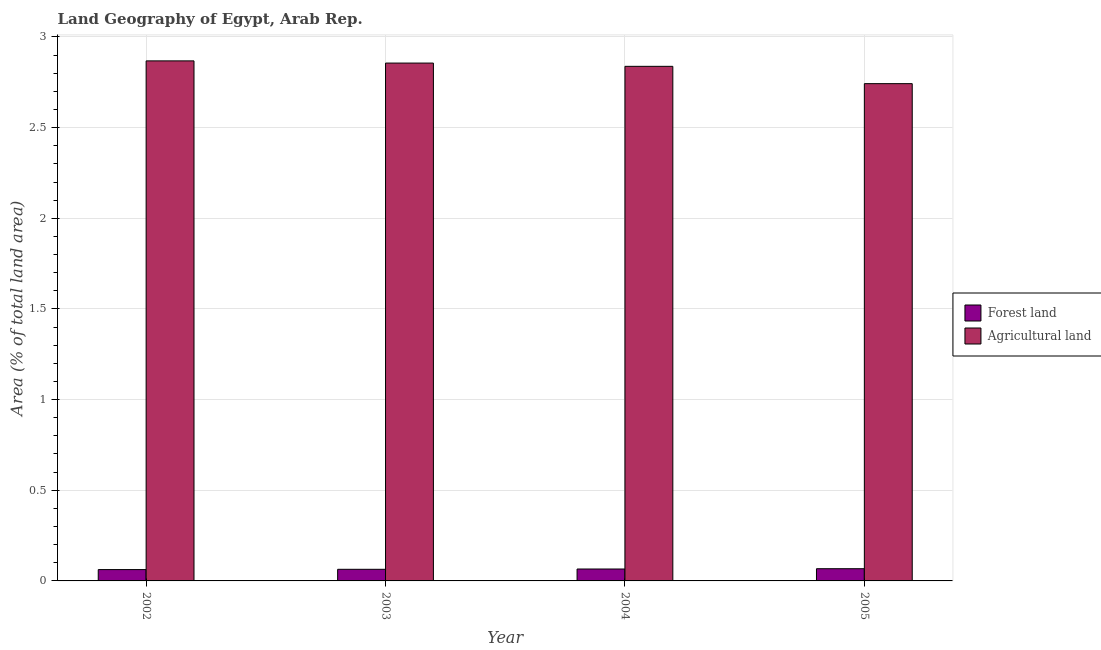How many groups of bars are there?
Your response must be concise. 4. Are the number of bars on each tick of the X-axis equal?
Your answer should be very brief. Yes. How many bars are there on the 3rd tick from the left?
Your answer should be compact. 2. How many bars are there on the 1st tick from the right?
Ensure brevity in your answer.  2. What is the label of the 4th group of bars from the left?
Offer a terse response. 2005. In how many cases, is the number of bars for a given year not equal to the number of legend labels?
Give a very brief answer. 0. What is the percentage of land area under agriculture in 2003?
Your answer should be compact. 2.86. Across all years, what is the maximum percentage of land area under agriculture?
Your response must be concise. 2.87. Across all years, what is the minimum percentage of land area under forests?
Provide a short and direct response. 0.06. In which year was the percentage of land area under agriculture minimum?
Provide a succinct answer. 2005. What is the total percentage of land area under agriculture in the graph?
Offer a very short reply. 11.3. What is the difference between the percentage of land area under forests in 2002 and that in 2005?
Your answer should be compact. -0. What is the difference between the percentage of land area under forests in 2003 and the percentage of land area under agriculture in 2004?
Offer a very short reply. -0. What is the average percentage of land area under agriculture per year?
Make the answer very short. 2.83. What is the ratio of the percentage of land area under forests in 2003 to that in 2005?
Provide a short and direct response. 0.95. What is the difference between the highest and the second highest percentage of land area under forests?
Offer a very short reply. 0. What is the difference between the highest and the lowest percentage of land area under agriculture?
Offer a terse response. 0.13. In how many years, is the percentage of land area under agriculture greater than the average percentage of land area under agriculture taken over all years?
Provide a succinct answer. 3. Is the sum of the percentage of land area under forests in 2002 and 2004 greater than the maximum percentage of land area under agriculture across all years?
Provide a short and direct response. Yes. What does the 1st bar from the left in 2002 represents?
Offer a very short reply. Forest land. What does the 2nd bar from the right in 2003 represents?
Keep it short and to the point. Forest land. How many bars are there?
Offer a very short reply. 8. How many years are there in the graph?
Your response must be concise. 4. What is the difference between two consecutive major ticks on the Y-axis?
Give a very brief answer. 0.5. Does the graph contain any zero values?
Your answer should be very brief. No. Does the graph contain grids?
Provide a succinct answer. Yes. Where does the legend appear in the graph?
Make the answer very short. Center right. How are the legend labels stacked?
Give a very brief answer. Vertical. What is the title of the graph?
Keep it short and to the point. Land Geography of Egypt, Arab Rep. Does "Residents" appear as one of the legend labels in the graph?
Offer a terse response. No. What is the label or title of the X-axis?
Offer a very short reply. Year. What is the label or title of the Y-axis?
Ensure brevity in your answer.  Area (% of total land area). What is the Area (% of total land area) in Forest land in 2002?
Offer a very short reply. 0.06. What is the Area (% of total land area) in Agricultural land in 2002?
Your response must be concise. 2.87. What is the Area (% of total land area) in Forest land in 2003?
Ensure brevity in your answer.  0.06. What is the Area (% of total land area) in Agricultural land in 2003?
Your answer should be compact. 2.86. What is the Area (% of total land area) of Forest land in 2004?
Provide a short and direct response. 0.07. What is the Area (% of total land area) of Agricultural land in 2004?
Keep it short and to the point. 2.84. What is the Area (% of total land area) in Forest land in 2005?
Offer a very short reply. 0.07. What is the Area (% of total land area) in Agricultural land in 2005?
Provide a succinct answer. 2.74. Across all years, what is the maximum Area (% of total land area) in Forest land?
Your answer should be compact. 0.07. Across all years, what is the maximum Area (% of total land area) in Agricultural land?
Your response must be concise. 2.87. Across all years, what is the minimum Area (% of total land area) in Forest land?
Your answer should be very brief. 0.06. Across all years, what is the minimum Area (% of total land area) of Agricultural land?
Ensure brevity in your answer.  2.74. What is the total Area (% of total land area) of Forest land in the graph?
Provide a short and direct response. 0.26. What is the total Area (% of total land area) in Agricultural land in the graph?
Provide a succinct answer. 11.3. What is the difference between the Area (% of total land area) of Forest land in 2002 and that in 2003?
Keep it short and to the point. -0. What is the difference between the Area (% of total land area) in Agricultural land in 2002 and that in 2003?
Provide a succinct answer. 0.01. What is the difference between the Area (% of total land area) of Forest land in 2002 and that in 2004?
Provide a short and direct response. -0. What is the difference between the Area (% of total land area) of Agricultural land in 2002 and that in 2004?
Your answer should be very brief. 0.03. What is the difference between the Area (% of total land area) of Forest land in 2002 and that in 2005?
Offer a very short reply. -0. What is the difference between the Area (% of total land area) in Agricultural land in 2002 and that in 2005?
Provide a succinct answer. 0.13. What is the difference between the Area (% of total land area) in Forest land in 2003 and that in 2004?
Keep it short and to the point. -0. What is the difference between the Area (% of total land area) of Agricultural land in 2003 and that in 2004?
Give a very brief answer. 0.02. What is the difference between the Area (% of total land area) of Forest land in 2003 and that in 2005?
Your response must be concise. -0. What is the difference between the Area (% of total land area) of Agricultural land in 2003 and that in 2005?
Offer a very short reply. 0.11. What is the difference between the Area (% of total land area) in Forest land in 2004 and that in 2005?
Give a very brief answer. -0. What is the difference between the Area (% of total land area) in Agricultural land in 2004 and that in 2005?
Ensure brevity in your answer.  0.1. What is the difference between the Area (% of total land area) in Forest land in 2002 and the Area (% of total land area) in Agricultural land in 2003?
Your answer should be compact. -2.79. What is the difference between the Area (% of total land area) of Forest land in 2002 and the Area (% of total land area) of Agricultural land in 2004?
Give a very brief answer. -2.78. What is the difference between the Area (% of total land area) in Forest land in 2002 and the Area (% of total land area) in Agricultural land in 2005?
Keep it short and to the point. -2.68. What is the difference between the Area (% of total land area) in Forest land in 2003 and the Area (% of total land area) in Agricultural land in 2004?
Make the answer very short. -2.77. What is the difference between the Area (% of total land area) in Forest land in 2003 and the Area (% of total land area) in Agricultural land in 2005?
Keep it short and to the point. -2.68. What is the difference between the Area (% of total land area) of Forest land in 2004 and the Area (% of total land area) of Agricultural land in 2005?
Your response must be concise. -2.68. What is the average Area (% of total land area) in Forest land per year?
Make the answer very short. 0.06. What is the average Area (% of total land area) of Agricultural land per year?
Your answer should be very brief. 2.83. In the year 2002, what is the difference between the Area (% of total land area) in Forest land and Area (% of total land area) in Agricultural land?
Your response must be concise. -2.81. In the year 2003, what is the difference between the Area (% of total land area) of Forest land and Area (% of total land area) of Agricultural land?
Your response must be concise. -2.79. In the year 2004, what is the difference between the Area (% of total land area) in Forest land and Area (% of total land area) in Agricultural land?
Your response must be concise. -2.77. In the year 2005, what is the difference between the Area (% of total land area) of Forest land and Area (% of total land area) of Agricultural land?
Your answer should be very brief. -2.68. What is the ratio of the Area (% of total land area) of Forest land in 2002 to that in 2003?
Ensure brevity in your answer.  0.97. What is the ratio of the Area (% of total land area) in Agricultural land in 2002 to that in 2003?
Offer a terse response. 1. What is the ratio of the Area (% of total land area) in Forest land in 2002 to that in 2004?
Give a very brief answer. 0.95. What is the ratio of the Area (% of total land area) in Agricultural land in 2002 to that in 2004?
Keep it short and to the point. 1.01. What is the ratio of the Area (% of total land area) in Forest land in 2002 to that in 2005?
Provide a short and direct response. 0.93. What is the ratio of the Area (% of total land area) in Agricultural land in 2002 to that in 2005?
Provide a succinct answer. 1.05. What is the ratio of the Area (% of total land area) in Forest land in 2003 to that in 2004?
Your answer should be very brief. 0.98. What is the ratio of the Area (% of total land area) in Agricultural land in 2003 to that in 2004?
Give a very brief answer. 1.01. What is the ratio of the Area (% of total land area) in Forest land in 2003 to that in 2005?
Give a very brief answer. 0.95. What is the ratio of the Area (% of total land area) in Agricultural land in 2003 to that in 2005?
Give a very brief answer. 1.04. What is the ratio of the Area (% of total land area) in Forest land in 2004 to that in 2005?
Your response must be concise. 0.98. What is the ratio of the Area (% of total land area) of Agricultural land in 2004 to that in 2005?
Provide a short and direct response. 1.03. What is the difference between the highest and the second highest Area (% of total land area) in Forest land?
Offer a very short reply. 0. What is the difference between the highest and the second highest Area (% of total land area) of Agricultural land?
Your response must be concise. 0.01. What is the difference between the highest and the lowest Area (% of total land area) of Forest land?
Keep it short and to the point. 0. What is the difference between the highest and the lowest Area (% of total land area) in Agricultural land?
Keep it short and to the point. 0.13. 